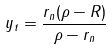Convert formula to latex. <formula><loc_0><loc_0><loc_500><loc_500>y _ { t } = \frac { r _ { n } ( \rho - R ) } { \rho - r _ { n } }</formula> 